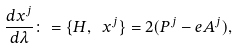<formula> <loc_0><loc_0><loc_500><loc_500>\frac { d x ^ { j } } { d \lambda } \colon = \{ H , \ x ^ { j } \} = 2 ( P ^ { j } - e A ^ { j } ) ,</formula> 